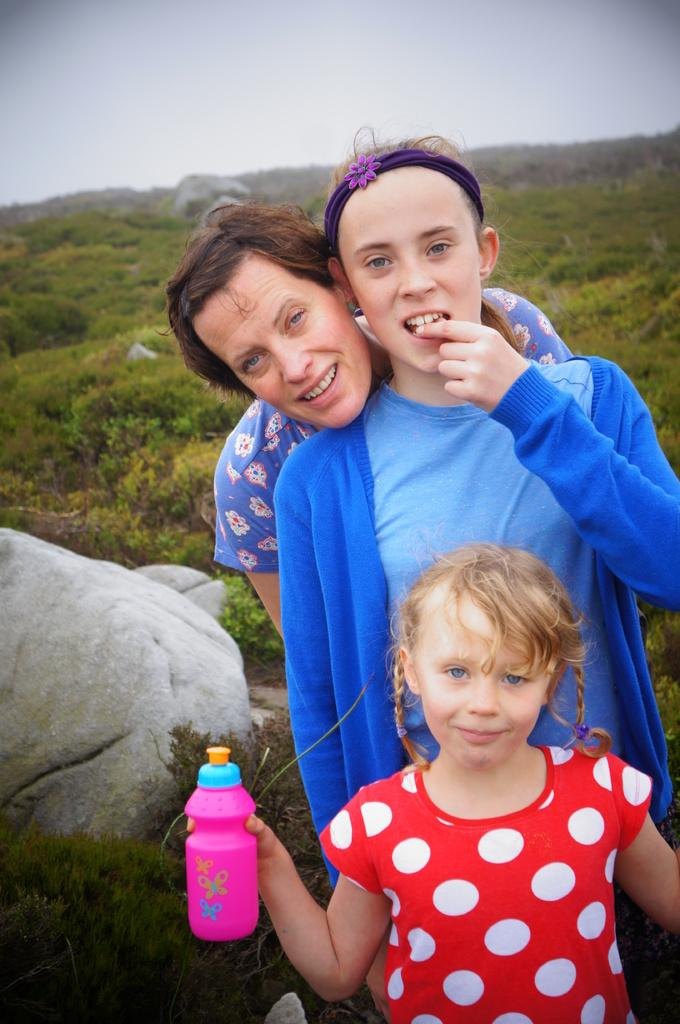How many people are present in the image? There are three people in the image. What is one person holding in the image? One person is holding a bottle. What can be seen in the background of the image? There are trees, a rock, and the sky visible in the background of the image. What type of lizards can be seen participating in the competition in the image? There are no lizards or competition present in the image. What is the glue used for in the image? There is no glue present in the image. 